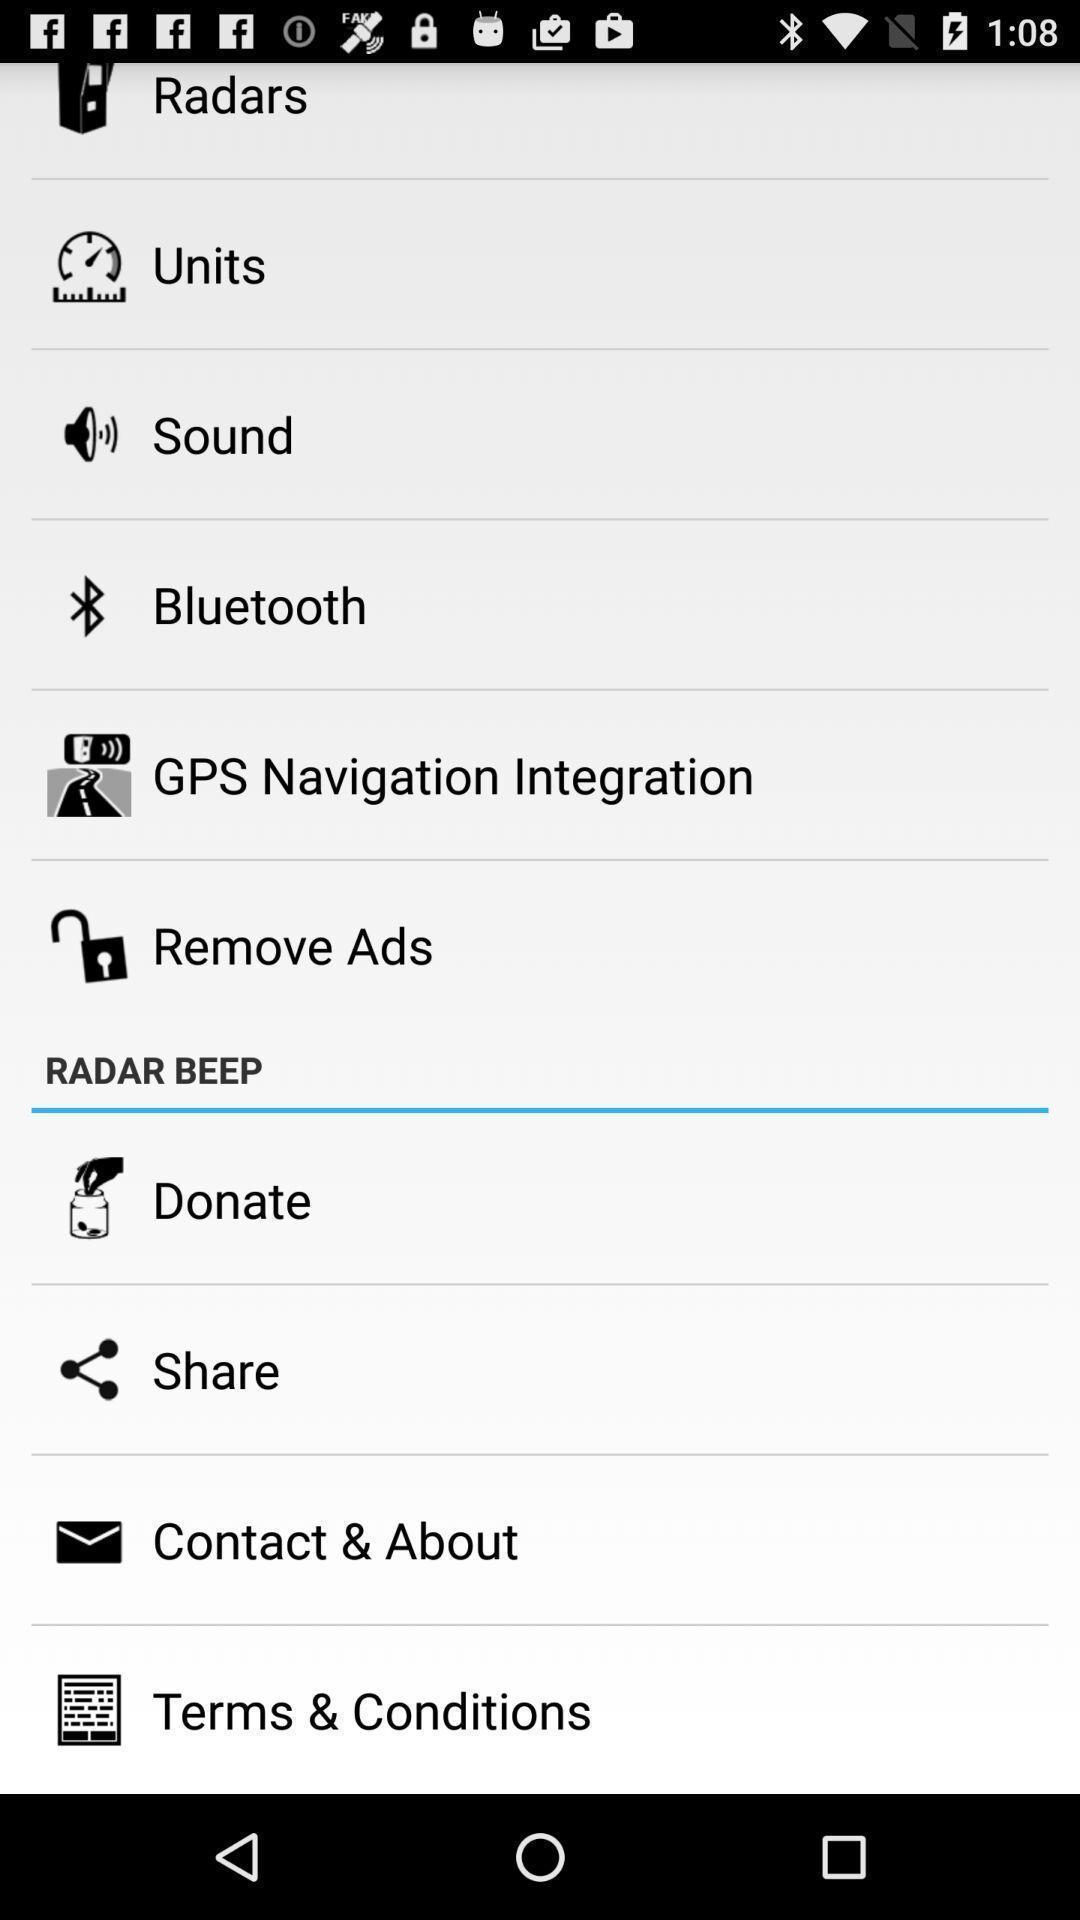Provide a detailed account of this screenshot. Page showing list of options. 